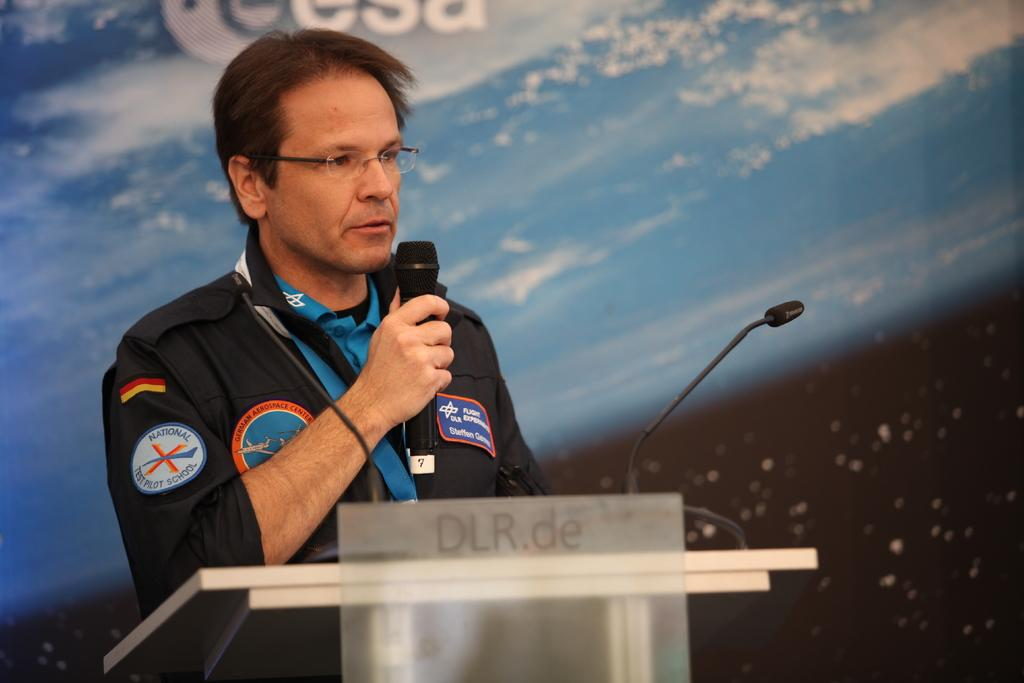What is the person in the image doing? The person is standing beside a speaker stand and holding a mic. What else can be seen in the image related to the person's activity? There is a mic with a stand in the image. Is there any text visible in the image? Yes, there is a banner with text on the backside. Can you see the person's aunt in the image? There is no mention of an aunt in the image, so we cannot determine if the person's aunt is present. 